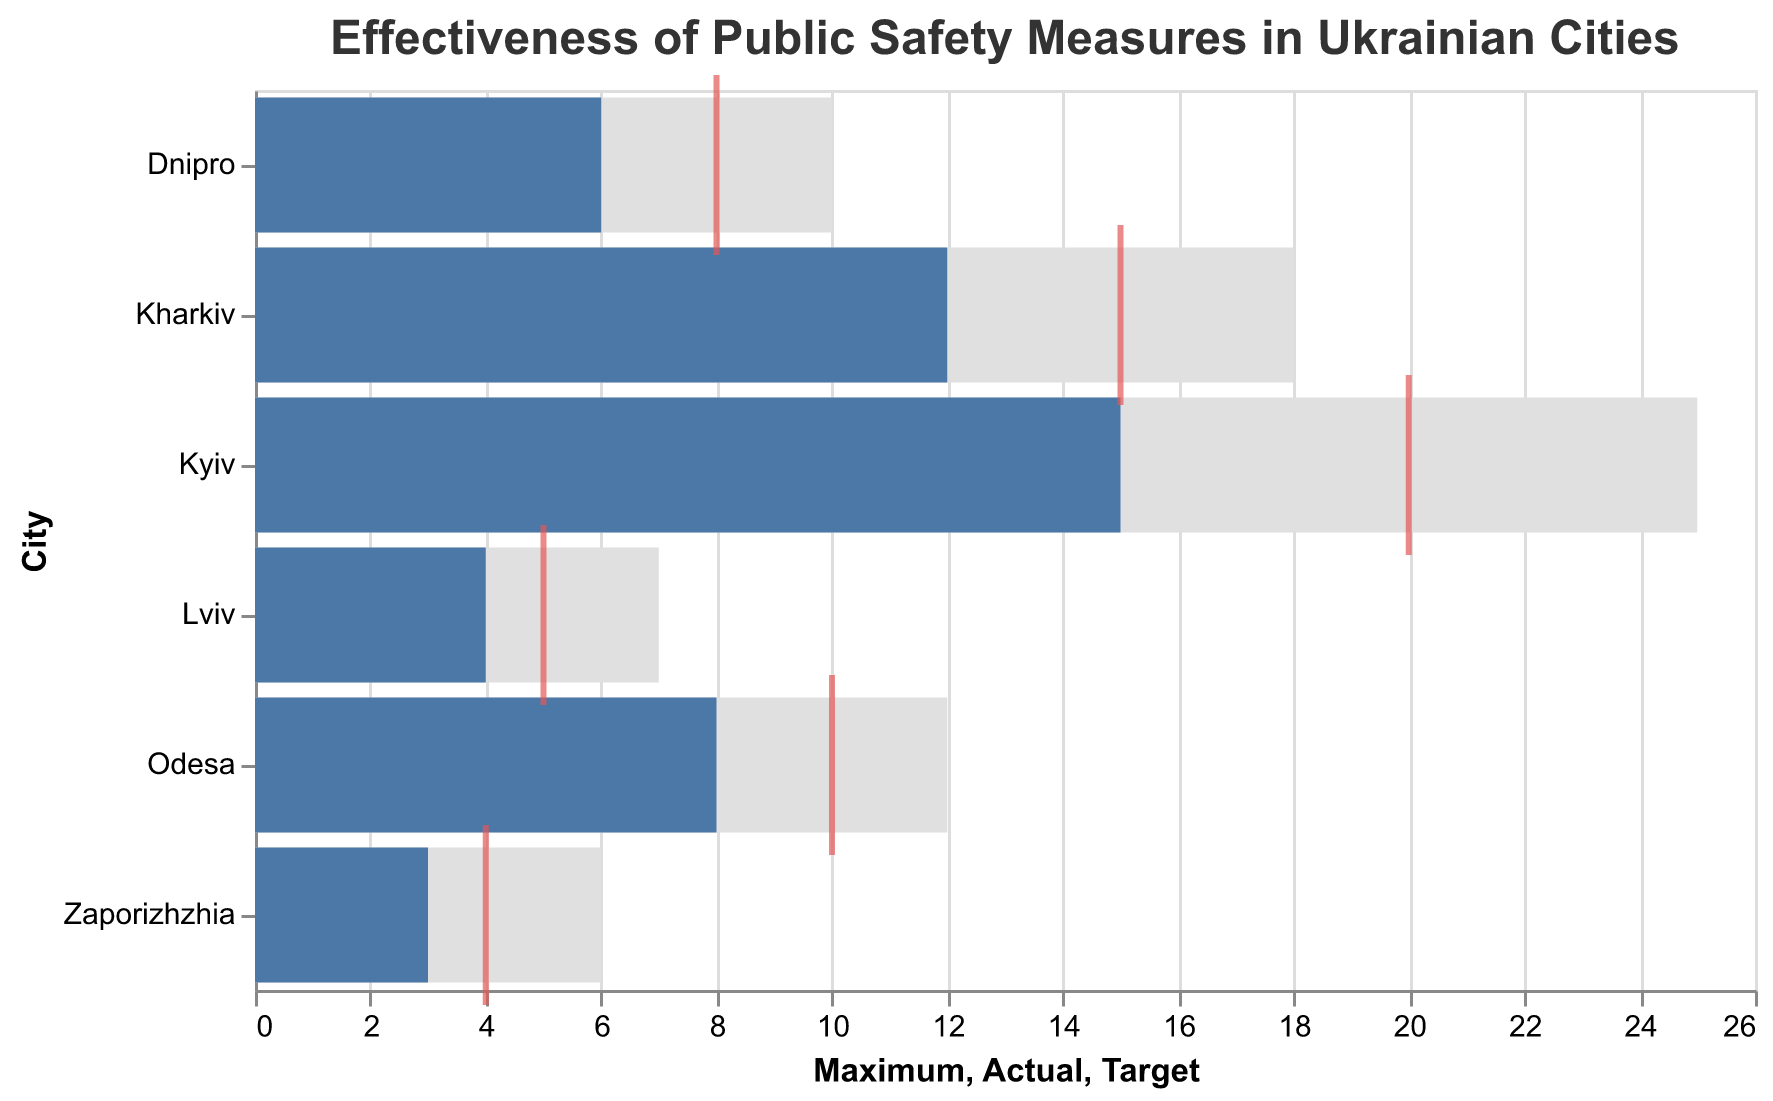What is the title of the figure? The title is located at the top of the chart and serves as an introduction to the visual data.
Answer: Effectiveness of Public Safety Measures in Ukrainian Cities Which city has the highest actual effectiveness value? By observing the bars representing the actual values, you can see that the bar that reached the highest point on the x-axis is for Kyiv.
Answer: Kyiv How does Lviv's actual effectiveness value compare to its target value? Lviv's actual value is represented by the blue bar, and its target value is indicated by the red tick mark. The actual value (4) is less than the target value (5).
Answer: It is less than the target Which measure has achieved its target most closely? By examining the proximity of the blue bars (actual values) to the red tick marks (target values), Kharkiv's measure is closest, with an actual value (12) near its target (15).
Answer: Kharkiv How far below its maximum value is Dnipro's actual effectiveness value? For Dnipro, the maximum value is 10, and the actual value is 6. The difference is calculated as 10 - 6.
Answer: 4 What is the combined target value for all cities? Adding the target values together: 20 (Kyiv) + 15 (Kharkiv) + 10 (Odesa) + 8 (Dnipro) + 5 (Lviv) + 4 (Zaporizhzhia) gives the total.
Answer: 62 Which city demonstrates the least effective measure based on actual values? The smallest blue bar indicates the least effective measure, which corresponds to Zaporizhzhia with an actual value of 3.
Answer: Zaporizhzhia In which cities are the measures still significantly under their target values? By comparing the actual values (blue bars) to the target values (red tick marks), significant underperformance is noticeable in Kyiv (actual 15, target 20) and Dnipro (actual 6, target 8).
Answer: Kyiv, Dnipro Are there any cities where the actual effectiveness meets or exceeds the maximum value? By comparing all actual values (blue bars) to the respective maximum values, none of the cities meet or exceed their maximum values.
Answer: No 